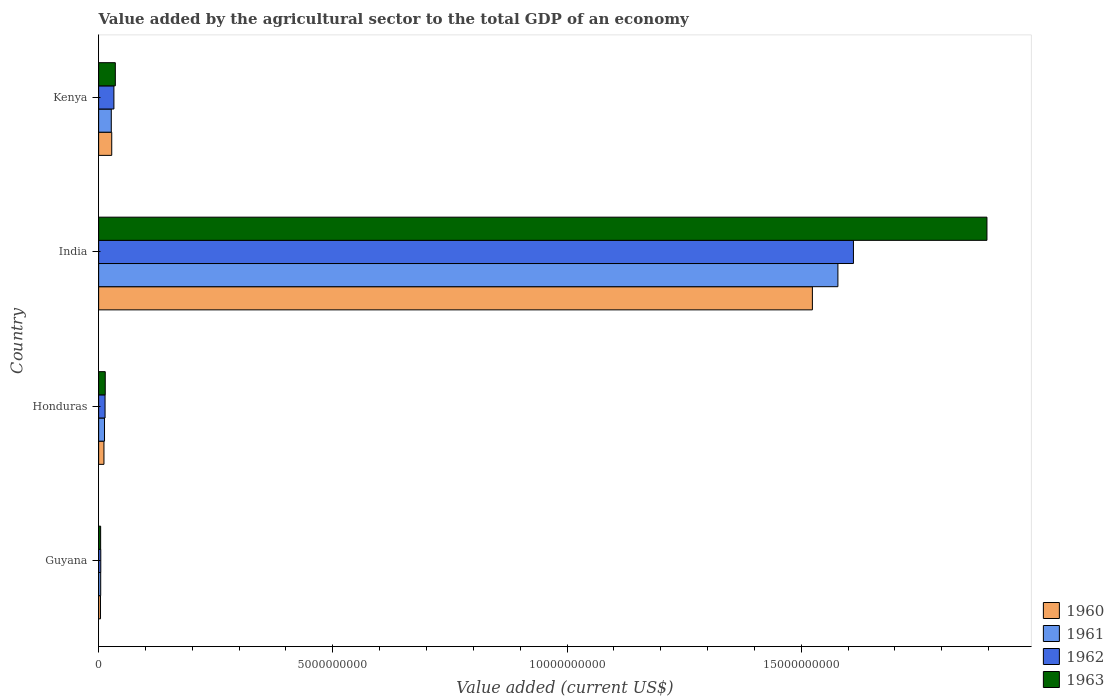How many bars are there on the 2nd tick from the top?
Offer a very short reply. 4. What is the label of the 3rd group of bars from the top?
Ensure brevity in your answer.  Honduras. In how many cases, is the number of bars for a given country not equal to the number of legend labels?
Offer a very short reply. 0. What is the value added by the agricultural sector to the total GDP in 1962 in Kenya?
Offer a terse response. 3.26e+08. Across all countries, what is the maximum value added by the agricultural sector to the total GDP in 1963?
Provide a short and direct response. 1.90e+1. Across all countries, what is the minimum value added by the agricultural sector to the total GDP in 1963?
Ensure brevity in your answer.  4.30e+07. In which country was the value added by the agricultural sector to the total GDP in 1963 minimum?
Offer a very short reply. Guyana. What is the total value added by the agricultural sector to the total GDP in 1961 in the graph?
Offer a very short reply. 1.62e+1. What is the difference between the value added by the agricultural sector to the total GDP in 1963 in Honduras and that in India?
Provide a short and direct response. -1.88e+1. What is the difference between the value added by the agricultural sector to the total GDP in 1962 in India and the value added by the agricultural sector to the total GDP in 1961 in Honduras?
Keep it short and to the point. 1.60e+1. What is the average value added by the agricultural sector to the total GDP in 1961 per country?
Your answer should be very brief. 4.06e+09. What is the difference between the value added by the agricultural sector to the total GDP in 1961 and value added by the agricultural sector to the total GDP in 1960 in Kenya?
Make the answer very short. -9.51e+06. In how many countries, is the value added by the agricultural sector to the total GDP in 1961 greater than 1000000000 US$?
Make the answer very short. 1. What is the ratio of the value added by the agricultural sector to the total GDP in 1961 in Guyana to that in Kenya?
Keep it short and to the point. 0.16. Is the difference between the value added by the agricultural sector to the total GDP in 1961 in Guyana and India greater than the difference between the value added by the agricultural sector to the total GDP in 1960 in Guyana and India?
Provide a succinct answer. No. What is the difference between the highest and the second highest value added by the agricultural sector to the total GDP in 1961?
Provide a short and direct response. 1.55e+1. What is the difference between the highest and the lowest value added by the agricultural sector to the total GDP in 1960?
Provide a succinct answer. 1.52e+1. In how many countries, is the value added by the agricultural sector to the total GDP in 1962 greater than the average value added by the agricultural sector to the total GDP in 1962 taken over all countries?
Provide a short and direct response. 1. Is the sum of the value added by the agricultural sector to the total GDP in 1961 in Guyana and India greater than the maximum value added by the agricultural sector to the total GDP in 1962 across all countries?
Make the answer very short. No. Is it the case that in every country, the sum of the value added by the agricultural sector to the total GDP in 1961 and value added by the agricultural sector to the total GDP in 1962 is greater than the sum of value added by the agricultural sector to the total GDP in 1963 and value added by the agricultural sector to the total GDP in 1960?
Keep it short and to the point. No. What does the 1st bar from the top in Kenya represents?
Your response must be concise. 1963. Is it the case that in every country, the sum of the value added by the agricultural sector to the total GDP in 1960 and value added by the agricultural sector to the total GDP in 1962 is greater than the value added by the agricultural sector to the total GDP in 1961?
Your answer should be very brief. Yes. Are all the bars in the graph horizontal?
Your response must be concise. Yes. How many countries are there in the graph?
Give a very brief answer. 4. What is the difference between two consecutive major ticks on the X-axis?
Ensure brevity in your answer.  5.00e+09. Does the graph contain any zero values?
Provide a succinct answer. No. Does the graph contain grids?
Give a very brief answer. No. How many legend labels are there?
Make the answer very short. 4. What is the title of the graph?
Keep it short and to the point. Value added by the agricultural sector to the total GDP of an economy. Does "1987" appear as one of the legend labels in the graph?
Keep it short and to the point. No. What is the label or title of the X-axis?
Your answer should be compact. Value added (current US$). What is the label or title of the Y-axis?
Ensure brevity in your answer.  Country. What is the Value added (current US$) of 1960 in Guyana?
Keep it short and to the point. 4.01e+07. What is the Value added (current US$) of 1961 in Guyana?
Offer a terse response. 4.43e+07. What is the Value added (current US$) in 1962 in Guyana?
Ensure brevity in your answer.  4.57e+07. What is the Value added (current US$) of 1963 in Guyana?
Offer a very short reply. 4.30e+07. What is the Value added (current US$) in 1960 in Honduras?
Your response must be concise. 1.14e+08. What is the Value added (current US$) in 1961 in Honduras?
Your answer should be very brief. 1.26e+08. What is the Value added (current US$) in 1962 in Honduras?
Give a very brief answer. 1.37e+08. What is the Value added (current US$) of 1963 in Honduras?
Your response must be concise. 1.41e+08. What is the Value added (current US$) in 1960 in India?
Offer a terse response. 1.52e+1. What is the Value added (current US$) of 1961 in India?
Keep it short and to the point. 1.58e+1. What is the Value added (current US$) of 1962 in India?
Provide a short and direct response. 1.61e+1. What is the Value added (current US$) in 1963 in India?
Ensure brevity in your answer.  1.90e+1. What is the Value added (current US$) in 1960 in Kenya?
Your answer should be compact. 2.80e+08. What is the Value added (current US$) in 1961 in Kenya?
Provide a short and direct response. 2.70e+08. What is the Value added (current US$) in 1962 in Kenya?
Offer a terse response. 3.26e+08. What is the Value added (current US$) in 1963 in Kenya?
Your answer should be compact. 3.56e+08. Across all countries, what is the maximum Value added (current US$) in 1960?
Offer a terse response. 1.52e+1. Across all countries, what is the maximum Value added (current US$) in 1961?
Keep it short and to the point. 1.58e+1. Across all countries, what is the maximum Value added (current US$) of 1962?
Keep it short and to the point. 1.61e+1. Across all countries, what is the maximum Value added (current US$) in 1963?
Offer a very short reply. 1.90e+1. Across all countries, what is the minimum Value added (current US$) of 1960?
Offer a terse response. 4.01e+07. Across all countries, what is the minimum Value added (current US$) of 1961?
Your response must be concise. 4.43e+07. Across all countries, what is the minimum Value added (current US$) of 1962?
Ensure brevity in your answer.  4.57e+07. Across all countries, what is the minimum Value added (current US$) of 1963?
Provide a succinct answer. 4.30e+07. What is the total Value added (current US$) in 1960 in the graph?
Your answer should be compact. 1.57e+1. What is the total Value added (current US$) in 1961 in the graph?
Offer a very short reply. 1.62e+1. What is the total Value added (current US$) in 1962 in the graph?
Offer a very short reply. 1.66e+1. What is the total Value added (current US$) of 1963 in the graph?
Your answer should be compact. 1.95e+1. What is the difference between the Value added (current US$) of 1960 in Guyana and that in Honduras?
Your answer should be very brief. -7.34e+07. What is the difference between the Value added (current US$) in 1961 in Guyana and that in Honduras?
Your answer should be very brief. -8.13e+07. What is the difference between the Value added (current US$) of 1962 in Guyana and that in Honduras?
Your answer should be compact. -9.15e+07. What is the difference between the Value added (current US$) in 1963 in Guyana and that in Honduras?
Your answer should be very brief. -9.82e+07. What is the difference between the Value added (current US$) in 1960 in Guyana and that in India?
Offer a very short reply. -1.52e+1. What is the difference between the Value added (current US$) of 1961 in Guyana and that in India?
Give a very brief answer. -1.57e+1. What is the difference between the Value added (current US$) of 1962 in Guyana and that in India?
Provide a succinct answer. -1.61e+1. What is the difference between the Value added (current US$) of 1963 in Guyana and that in India?
Provide a succinct answer. -1.89e+1. What is the difference between the Value added (current US$) in 1960 in Guyana and that in Kenya?
Your answer should be very brief. -2.40e+08. What is the difference between the Value added (current US$) of 1961 in Guyana and that in Kenya?
Ensure brevity in your answer.  -2.26e+08. What is the difference between the Value added (current US$) of 1962 in Guyana and that in Kenya?
Offer a terse response. -2.80e+08. What is the difference between the Value added (current US$) of 1963 in Guyana and that in Kenya?
Make the answer very short. -3.13e+08. What is the difference between the Value added (current US$) in 1960 in Honduras and that in India?
Ensure brevity in your answer.  -1.51e+1. What is the difference between the Value added (current US$) in 1961 in Honduras and that in India?
Provide a short and direct response. -1.57e+1. What is the difference between the Value added (current US$) in 1962 in Honduras and that in India?
Give a very brief answer. -1.60e+1. What is the difference between the Value added (current US$) in 1963 in Honduras and that in India?
Your answer should be compact. -1.88e+1. What is the difference between the Value added (current US$) in 1960 in Honduras and that in Kenya?
Make the answer very short. -1.66e+08. What is the difference between the Value added (current US$) in 1961 in Honduras and that in Kenya?
Your answer should be very brief. -1.45e+08. What is the difference between the Value added (current US$) in 1962 in Honduras and that in Kenya?
Offer a terse response. -1.89e+08. What is the difference between the Value added (current US$) in 1963 in Honduras and that in Kenya?
Ensure brevity in your answer.  -2.15e+08. What is the difference between the Value added (current US$) of 1960 in India and that in Kenya?
Your answer should be very brief. 1.50e+1. What is the difference between the Value added (current US$) of 1961 in India and that in Kenya?
Offer a terse response. 1.55e+1. What is the difference between the Value added (current US$) of 1962 in India and that in Kenya?
Make the answer very short. 1.58e+1. What is the difference between the Value added (current US$) of 1963 in India and that in Kenya?
Your answer should be compact. 1.86e+1. What is the difference between the Value added (current US$) in 1960 in Guyana and the Value added (current US$) in 1961 in Honduras?
Give a very brief answer. -8.55e+07. What is the difference between the Value added (current US$) in 1960 in Guyana and the Value added (current US$) in 1962 in Honduras?
Offer a terse response. -9.71e+07. What is the difference between the Value added (current US$) in 1960 in Guyana and the Value added (current US$) in 1963 in Honduras?
Provide a succinct answer. -1.01e+08. What is the difference between the Value added (current US$) of 1961 in Guyana and the Value added (current US$) of 1962 in Honduras?
Your answer should be very brief. -9.29e+07. What is the difference between the Value added (current US$) in 1961 in Guyana and the Value added (current US$) in 1963 in Honduras?
Offer a terse response. -9.68e+07. What is the difference between the Value added (current US$) of 1962 in Guyana and the Value added (current US$) of 1963 in Honduras?
Your answer should be compact. -9.54e+07. What is the difference between the Value added (current US$) of 1960 in Guyana and the Value added (current US$) of 1961 in India?
Offer a terse response. -1.57e+1. What is the difference between the Value added (current US$) of 1960 in Guyana and the Value added (current US$) of 1962 in India?
Provide a short and direct response. -1.61e+1. What is the difference between the Value added (current US$) in 1960 in Guyana and the Value added (current US$) in 1963 in India?
Give a very brief answer. -1.89e+1. What is the difference between the Value added (current US$) in 1961 in Guyana and the Value added (current US$) in 1962 in India?
Provide a short and direct response. -1.61e+1. What is the difference between the Value added (current US$) of 1961 in Guyana and the Value added (current US$) of 1963 in India?
Your answer should be very brief. -1.89e+1. What is the difference between the Value added (current US$) in 1962 in Guyana and the Value added (current US$) in 1963 in India?
Offer a terse response. -1.89e+1. What is the difference between the Value added (current US$) in 1960 in Guyana and the Value added (current US$) in 1961 in Kenya?
Provide a succinct answer. -2.30e+08. What is the difference between the Value added (current US$) of 1960 in Guyana and the Value added (current US$) of 1962 in Kenya?
Offer a terse response. -2.86e+08. What is the difference between the Value added (current US$) in 1960 in Guyana and the Value added (current US$) in 1963 in Kenya?
Make the answer very short. -3.16e+08. What is the difference between the Value added (current US$) in 1961 in Guyana and the Value added (current US$) in 1962 in Kenya?
Your answer should be compact. -2.82e+08. What is the difference between the Value added (current US$) of 1961 in Guyana and the Value added (current US$) of 1963 in Kenya?
Your response must be concise. -3.12e+08. What is the difference between the Value added (current US$) of 1962 in Guyana and the Value added (current US$) of 1963 in Kenya?
Provide a short and direct response. -3.11e+08. What is the difference between the Value added (current US$) of 1960 in Honduras and the Value added (current US$) of 1961 in India?
Offer a very short reply. -1.57e+1. What is the difference between the Value added (current US$) in 1960 in Honduras and the Value added (current US$) in 1962 in India?
Your answer should be very brief. -1.60e+1. What is the difference between the Value added (current US$) in 1960 in Honduras and the Value added (current US$) in 1963 in India?
Ensure brevity in your answer.  -1.89e+1. What is the difference between the Value added (current US$) of 1961 in Honduras and the Value added (current US$) of 1962 in India?
Your answer should be compact. -1.60e+1. What is the difference between the Value added (current US$) of 1961 in Honduras and the Value added (current US$) of 1963 in India?
Offer a terse response. -1.88e+1. What is the difference between the Value added (current US$) in 1962 in Honduras and the Value added (current US$) in 1963 in India?
Make the answer very short. -1.88e+1. What is the difference between the Value added (current US$) of 1960 in Honduras and the Value added (current US$) of 1961 in Kenya?
Make the answer very short. -1.57e+08. What is the difference between the Value added (current US$) of 1960 in Honduras and the Value added (current US$) of 1962 in Kenya?
Offer a terse response. -2.13e+08. What is the difference between the Value added (current US$) in 1960 in Honduras and the Value added (current US$) in 1963 in Kenya?
Provide a succinct answer. -2.43e+08. What is the difference between the Value added (current US$) of 1961 in Honduras and the Value added (current US$) of 1962 in Kenya?
Provide a succinct answer. -2.01e+08. What is the difference between the Value added (current US$) of 1961 in Honduras and the Value added (current US$) of 1963 in Kenya?
Ensure brevity in your answer.  -2.31e+08. What is the difference between the Value added (current US$) of 1962 in Honduras and the Value added (current US$) of 1963 in Kenya?
Provide a succinct answer. -2.19e+08. What is the difference between the Value added (current US$) of 1960 in India and the Value added (current US$) of 1961 in Kenya?
Give a very brief answer. 1.50e+1. What is the difference between the Value added (current US$) of 1960 in India and the Value added (current US$) of 1962 in Kenya?
Give a very brief answer. 1.49e+1. What is the difference between the Value added (current US$) of 1960 in India and the Value added (current US$) of 1963 in Kenya?
Keep it short and to the point. 1.49e+1. What is the difference between the Value added (current US$) of 1961 in India and the Value added (current US$) of 1962 in Kenya?
Offer a terse response. 1.55e+1. What is the difference between the Value added (current US$) in 1961 in India and the Value added (current US$) in 1963 in Kenya?
Provide a short and direct response. 1.54e+1. What is the difference between the Value added (current US$) of 1962 in India and the Value added (current US$) of 1963 in Kenya?
Keep it short and to the point. 1.58e+1. What is the average Value added (current US$) of 1960 per country?
Provide a short and direct response. 3.92e+09. What is the average Value added (current US$) in 1961 per country?
Give a very brief answer. 4.06e+09. What is the average Value added (current US$) in 1962 per country?
Your answer should be compact. 4.16e+09. What is the average Value added (current US$) in 1963 per country?
Provide a succinct answer. 4.88e+09. What is the difference between the Value added (current US$) in 1960 and Value added (current US$) in 1961 in Guyana?
Your response must be concise. -4.20e+06. What is the difference between the Value added (current US$) in 1960 and Value added (current US$) in 1962 in Guyana?
Make the answer very short. -5.60e+06. What is the difference between the Value added (current US$) of 1960 and Value added (current US$) of 1963 in Guyana?
Offer a terse response. -2.86e+06. What is the difference between the Value added (current US$) in 1961 and Value added (current US$) in 1962 in Guyana?
Your response must be concise. -1.40e+06. What is the difference between the Value added (current US$) in 1961 and Value added (current US$) in 1963 in Guyana?
Offer a terse response. 1.34e+06. What is the difference between the Value added (current US$) of 1962 and Value added (current US$) of 1963 in Guyana?
Offer a terse response. 2.74e+06. What is the difference between the Value added (current US$) of 1960 and Value added (current US$) of 1961 in Honduras?
Your answer should be compact. -1.21e+07. What is the difference between the Value added (current US$) of 1960 and Value added (current US$) of 1962 in Honduras?
Make the answer very short. -2.38e+07. What is the difference between the Value added (current US$) in 1960 and Value added (current US$) in 1963 in Honduras?
Offer a terse response. -2.76e+07. What is the difference between the Value added (current US$) of 1961 and Value added (current US$) of 1962 in Honduras?
Offer a terse response. -1.16e+07. What is the difference between the Value added (current US$) in 1961 and Value added (current US$) in 1963 in Honduras?
Make the answer very short. -1.56e+07. What is the difference between the Value added (current US$) of 1962 and Value added (current US$) of 1963 in Honduras?
Your response must be concise. -3.90e+06. What is the difference between the Value added (current US$) in 1960 and Value added (current US$) in 1961 in India?
Your answer should be compact. -5.45e+08. What is the difference between the Value added (current US$) of 1960 and Value added (current US$) of 1962 in India?
Your answer should be compact. -8.76e+08. What is the difference between the Value added (current US$) in 1960 and Value added (current US$) in 1963 in India?
Give a very brief answer. -3.73e+09. What is the difference between the Value added (current US$) of 1961 and Value added (current US$) of 1962 in India?
Offer a very short reply. -3.32e+08. What is the difference between the Value added (current US$) of 1961 and Value added (current US$) of 1963 in India?
Make the answer very short. -3.18e+09. What is the difference between the Value added (current US$) of 1962 and Value added (current US$) of 1963 in India?
Give a very brief answer. -2.85e+09. What is the difference between the Value added (current US$) of 1960 and Value added (current US$) of 1961 in Kenya?
Provide a short and direct response. 9.51e+06. What is the difference between the Value added (current US$) of 1960 and Value added (current US$) of 1962 in Kenya?
Keep it short and to the point. -4.65e+07. What is the difference between the Value added (current US$) in 1960 and Value added (current US$) in 1963 in Kenya?
Give a very brief answer. -7.66e+07. What is the difference between the Value added (current US$) of 1961 and Value added (current US$) of 1962 in Kenya?
Provide a short and direct response. -5.60e+07. What is the difference between the Value added (current US$) of 1961 and Value added (current US$) of 1963 in Kenya?
Ensure brevity in your answer.  -8.61e+07. What is the difference between the Value added (current US$) in 1962 and Value added (current US$) in 1963 in Kenya?
Offer a very short reply. -3.01e+07. What is the ratio of the Value added (current US$) of 1960 in Guyana to that in Honduras?
Keep it short and to the point. 0.35. What is the ratio of the Value added (current US$) in 1961 in Guyana to that in Honduras?
Give a very brief answer. 0.35. What is the ratio of the Value added (current US$) in 1962 in Guyana to that in Honduras?
Make the answer very short. 0.33. What is the ratio of the Value added (current US$) in 1963 in Guyana to that in Honduras?
Your answer should be very brief. 0.3. What is the ratio of the Value added (current US$) of 1960 in Guyana to that in India?
Provide a succinct answer. 0. What is the ratio of the Value added (current US$) in 1961 in Guyana to that in India?
Your response must be concise. 0. What is the ratio of the Value added (current US$) in 1962 in Guyana to that in India?
Provide a succinct answer. 0. What is the ratio of the Value added (current US$) of 1963 in Guyana to that in India?
Provide a short and direct response. 0. What is the ratio of the Value added (current US$) of 1960 in Guyana to that in Kenya?
Your answer should be compact. 0.14. What is the ratio of the Value added (current US$) in 1961 in Guyana to that in Kenya?
Your answer should be very brief. 0.16. What is the ratio of the Value added (current US$) of 1962 in Guyana to that in Kenya?
Keep it short and to the point. 0.14. What is the ratio of the Value added (current US$) of 1963 in Guyana to that in Kenya?
Offer a terse response. 0.12. What is the ratio of the Value added (current US$) of 1960 in Honduras to that in India?
Your answer should be very brief. 0.01. What is the ratio of the Value added (current US$) of 1961 in Honduras to that in India?
Your response must be concise. 0.01. What is the ratio of the Value added (current US$) of 1962 in Honduras to that in India?
Provide a short and direct response. 0.01. What is the ratio of the Value added (current US$) of 1963 in Honduras to that in India?
Keep it short and to the point. 0.01. What is the ratio of the Value added (current US$) in 1960 in Honduras to that in Kenya?
Offer a very short reply. 0.41. What is the ratio of the Value added (current US$) in 1961 in Honduras to that in Kenya?
Keep it short and to the point. 0.46. What is the ratio of the Value added (current US$) in 1962 in Honduras to that in Kenya?
Your answer should be compact. 0.42. What is the ratio of the Value added (current US$) in 1963 in Honduras to that in Kenya?
Offer a terse response. 0.4. What is the ratio of the Value added (current US$) in 1960 in India to that in Kenya?
Your response must be concise. 54.48. What is the ratio of the Value added (current US$) of 1961 in India to that in Kenya?
Ensure brevity in your answer.  58.42. What is the ratio of the Value added (current US$) in 1962 in India to that in Kenya?
Make the answer very short. 49.4. What is the ratio of the Value added (current US$) in 1963 in India to that in Kenya?
Offer a very short reply. 53.23. What is the difference between the highest and the second highest Value added (current US$) in 1960?
Give a very brief answer. 1.50e+1. What is the difference between the highest and the second highest Value added (current US$) in 1961?
Your response must be concise. 1.55e+1. What is the difference between the highest and the second highest Value added (current US$) of 1962?
Give a very brief answer. 1.58e+1. What is the difference between the highest and the second highest Value added (current US$) of 1963?
Your answer should be compact. 1.86e+1. What is the difference between the highest and the lowest Value added (current US$) in 1960?
Provide a succinct answer. 1.52e+1. What is the difference between the highest and the lowest Value added (current US$) of 1961?
Provide a succinct answer. 1.57e+1. What is the difference between the highest and the lowest Value added (current US$) in 1962?
Give a very brief answer. 1.61e+1. What is the difference between the highest and the lowest Value added (current US$) of 1963?
Ensure brevity in your answer.  1.89e+1. 